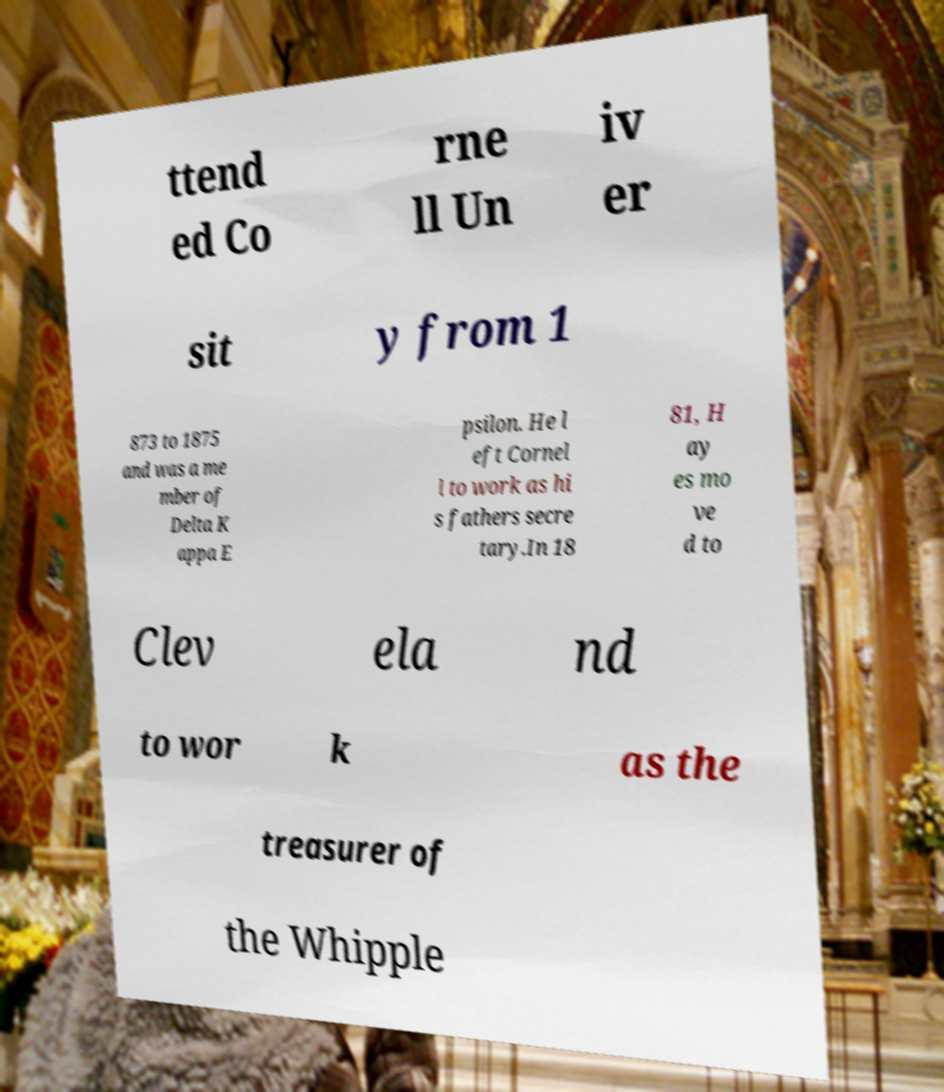Please identify and transcribe the text found in this image. ttend ed Co rne ll Un iv er sit y from 1 873 to 1875 and was a me mber of Delta K appa E psilon. He l eft Cornel l to work as hi s fathers secre tary.In 18 81, H ay es mo ve d to Clev ela nd to wor k as the treasurer of the Whipple 